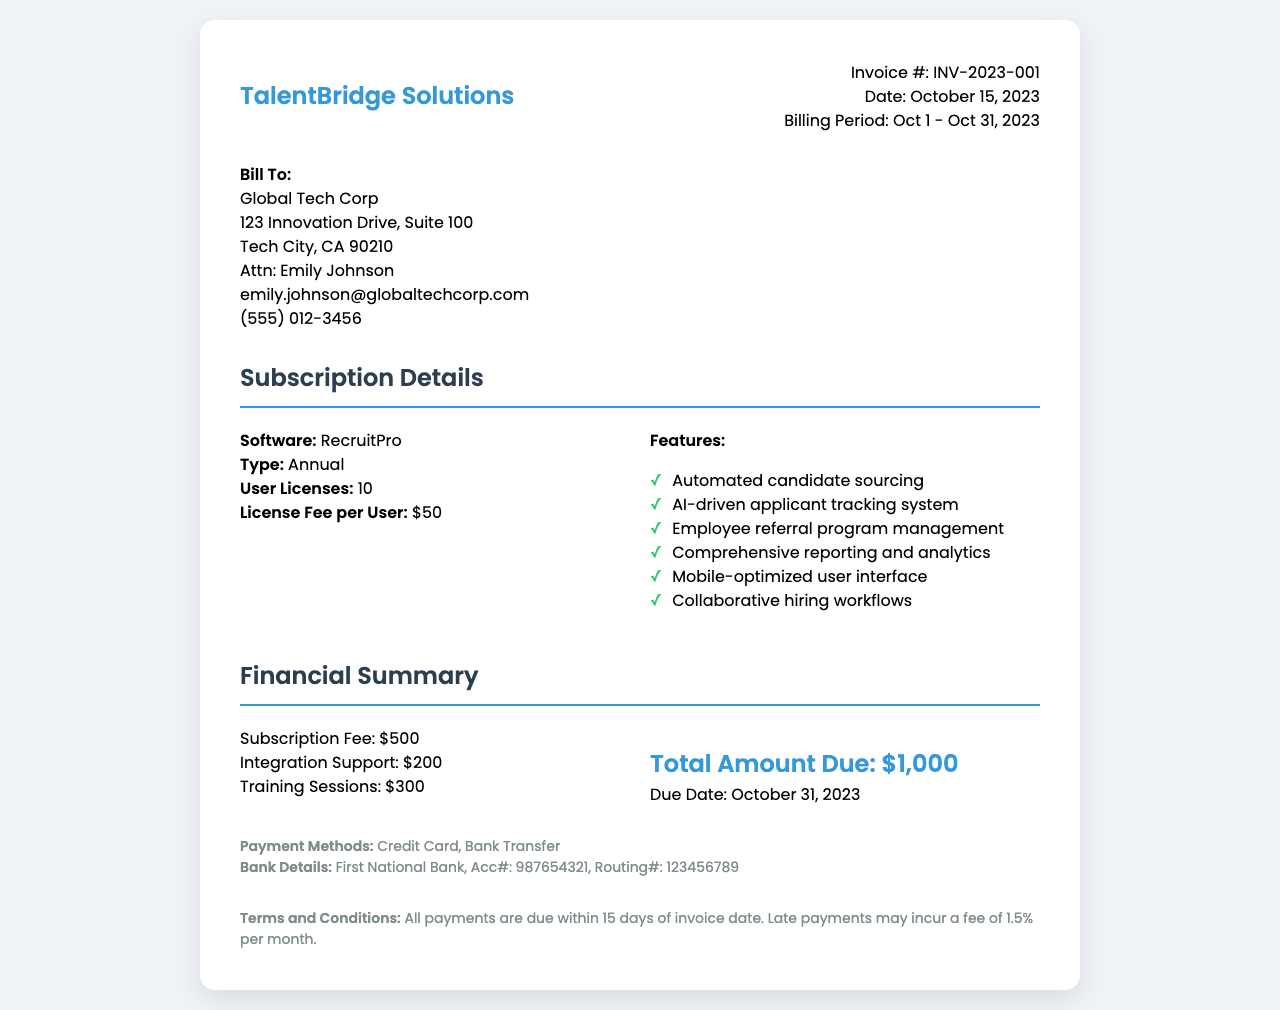What is the invoice number? The invoice number is displayed prominently at the top of the document under the invoice details section.
Answer: INV-2023-001 What is the billing period? The billing period indicates the timeframe for which the subscription fee is charged, located in the invoice details section.
Answer: Oct 1 - Oct 31, 2023 How many user licenses are included? The number of user licenses is specified in the subscription details for the software.
Answer: 10 What is the total amount due? The total amount due is calculated from the financial summary section, summarizing all costs related to the subscription.
Answer: $1,000 What is the due date for payment? The due date indicates when the total amount must be paid, found in the financial summary section.
Answer: October 31, 2023 What is the license fee per user? The license fee per user is mentioned in the subscription details for the software.
Answer: $50 What features are included in the subscription? The features list outlines the capabilities of the software and is part of the subscription details.
Answer: Automated candidate sourcing, AI-driven applicant tracking system, Employee referral program management, Comprehensive reporting and analytics, Mobile-optimized user interface, Collaborative hiring workflows What payment methods are available? The available payment methods are listed under the payment information section.
Answer: Credit Card, Bank Transfer What is the training session fee? The fee for training sessions is included in the financial summary, which details additional charges beyond the subscription fee.
Answer: $300 